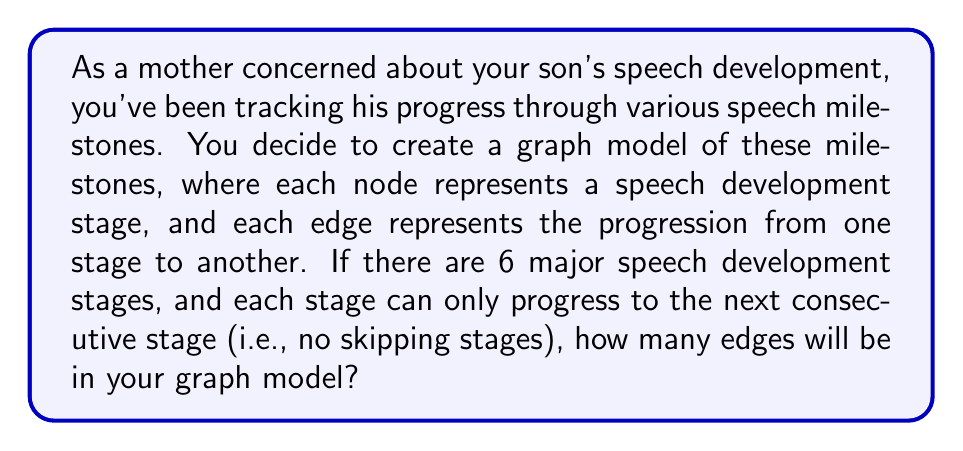Provide a solution to this math problem. Let's approach this step-by-step using graph theory:

1) First, let's visualize the graph. We have 6 nodes (representing the 6 speech development stages) arranged in a linear sequence.

2) In graph theory, this type of graph is known as a path graph, denoted as $P_6$.

3) In a path graph, each node (except the last one) is connected to the next node in the sequence. This represents the progression from one speech stage to the next.

4) To calculate the number of edges, we can use the formula for the number of edges in a path graph:

   For a path graph $P_n$ with $n$ nodes, the number of edges $E$ is given by:

   $$ E = n - 1 $$

5) In this case, we have 6 nodes, so $n = 6$.

6) Plugging this into our formula:

   $$ E = 6 - 1 = 5 $$

Therefore, your graph model of speech development stages will have 5 edges.

This makes intuitive sense as well: there's an edge from stage 1 to 2, 2 to 3, 3 to 4, 4 to 5, and 5 to 6, for a total of 5 edges.
Answer: 5 edges 